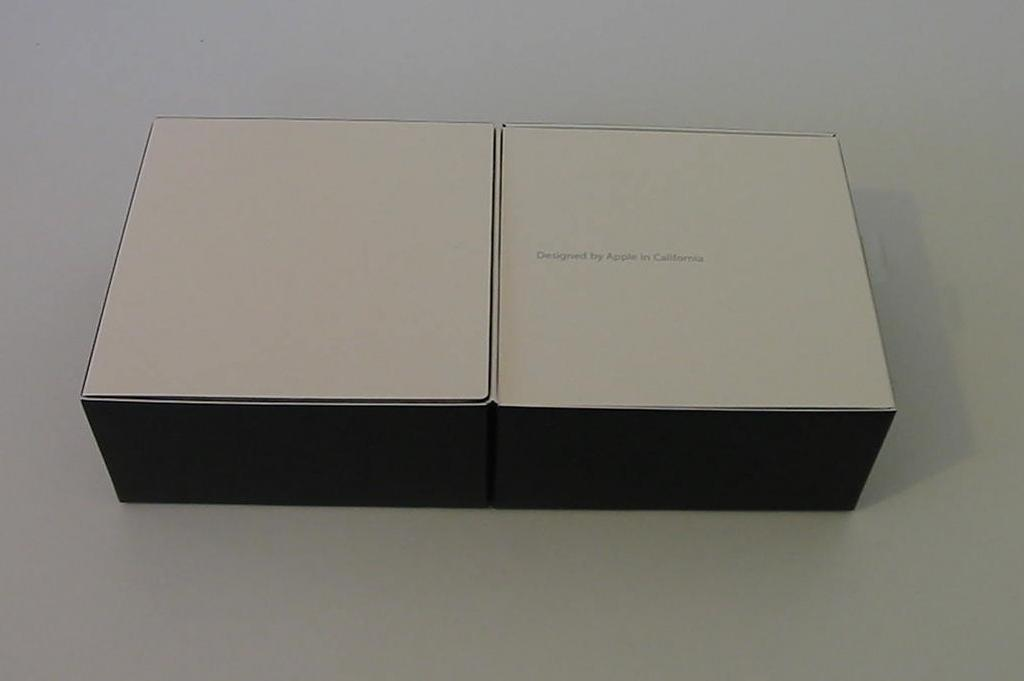What objects are on the table in the image? There are boxes on the table in the image. Can you describe the text on one of the boxes? There is text on the right side box. Where is the grandfather clock located in the image? There is no grandfather clock present in the image. What type of clocks are visible in the image? There are no clocks visible in the image. 